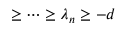<formula> <loc_0><loc_0><loc_500><loc_500>\geq \cdots \geq \lambda _ { n } \geq - d</formula> 